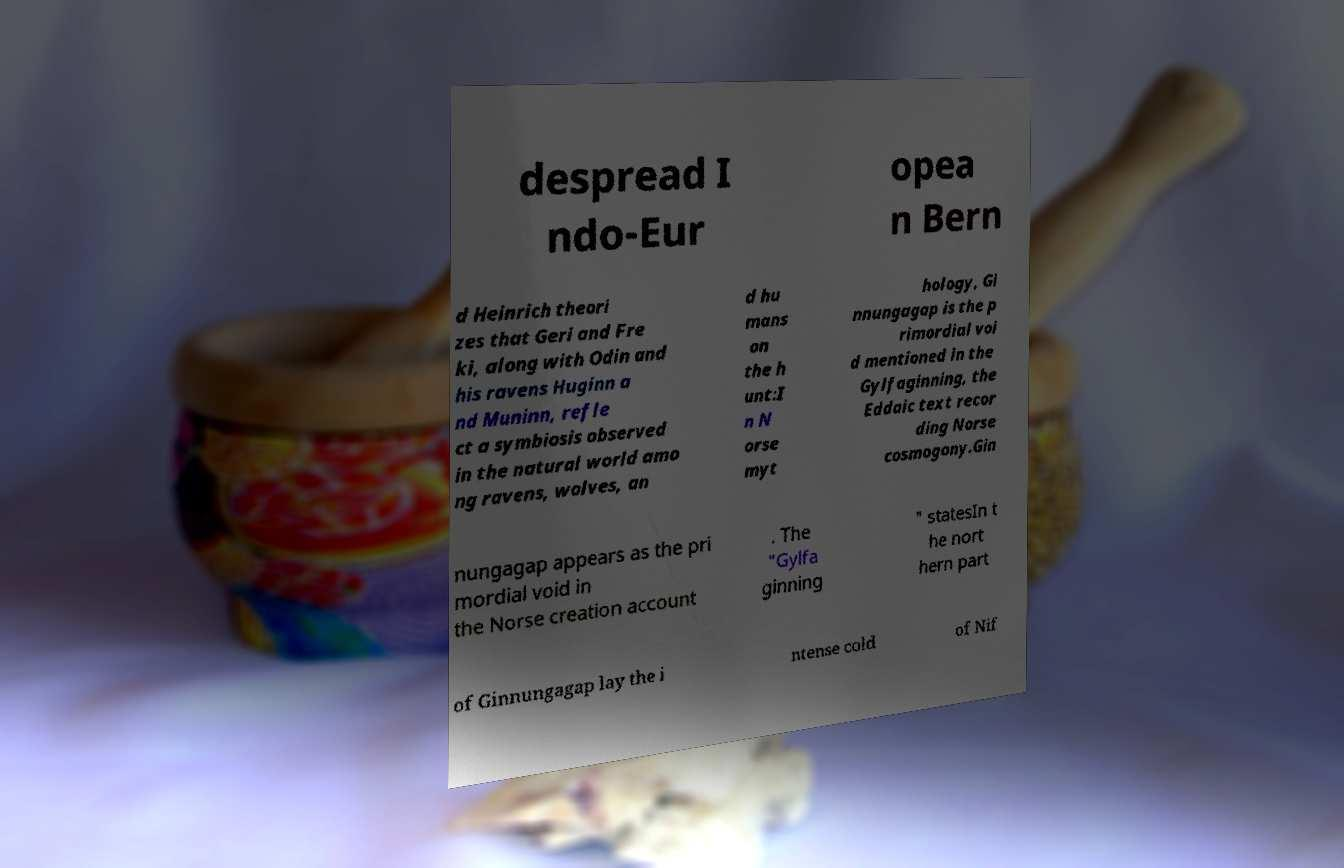There's text embedded in this image that I need extracted. Can you transcribe it verbatim? despread I ndo-Eur opea n Bern d Heinrich theori zes that Geri and Fre ki, along with Odin and his ravens Huginn a nd Muninn, refle ct a symbiosis observed in the natural world amo ng ravens, wolves, an d hu mans on the h unt:I n N orse myt hology, Gi nnungagap is the p rimordial voi d mentioned in the Gylfaginning, the Eddaic text recor ding Norse cosmogony.Gin nungagap appears as the pri mordial void in the Norse creation account . The "Gylfa ginning " statesIn t he nort hern part of Ginnungagap lay the i ntense cold of Nif 